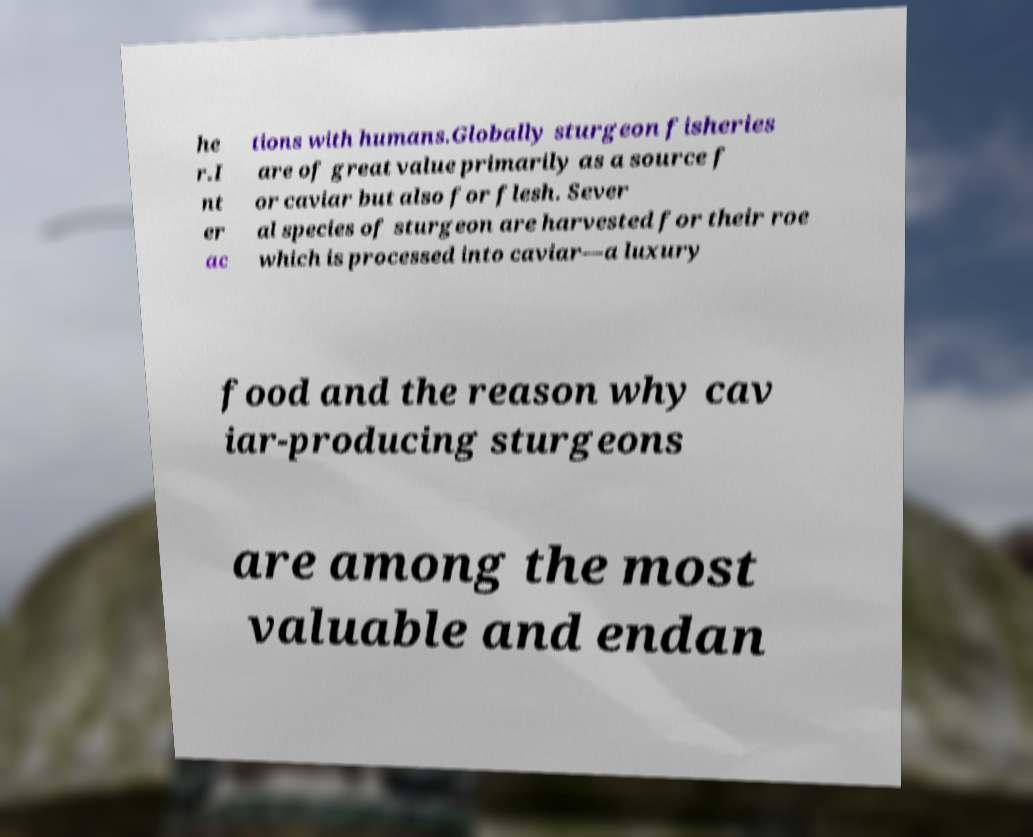Could you extract and type out the text from this image? he r.I nt er ac tions with humans.Globally sturgeon fisheries are of great value primarily as a source f or caviar but also for flesh. Sever al species of sturgeon are harvested for their roe which is processed into caviar—a luxury food and the reason why cav iar-producing sturgeons are among the most valuable and endan 